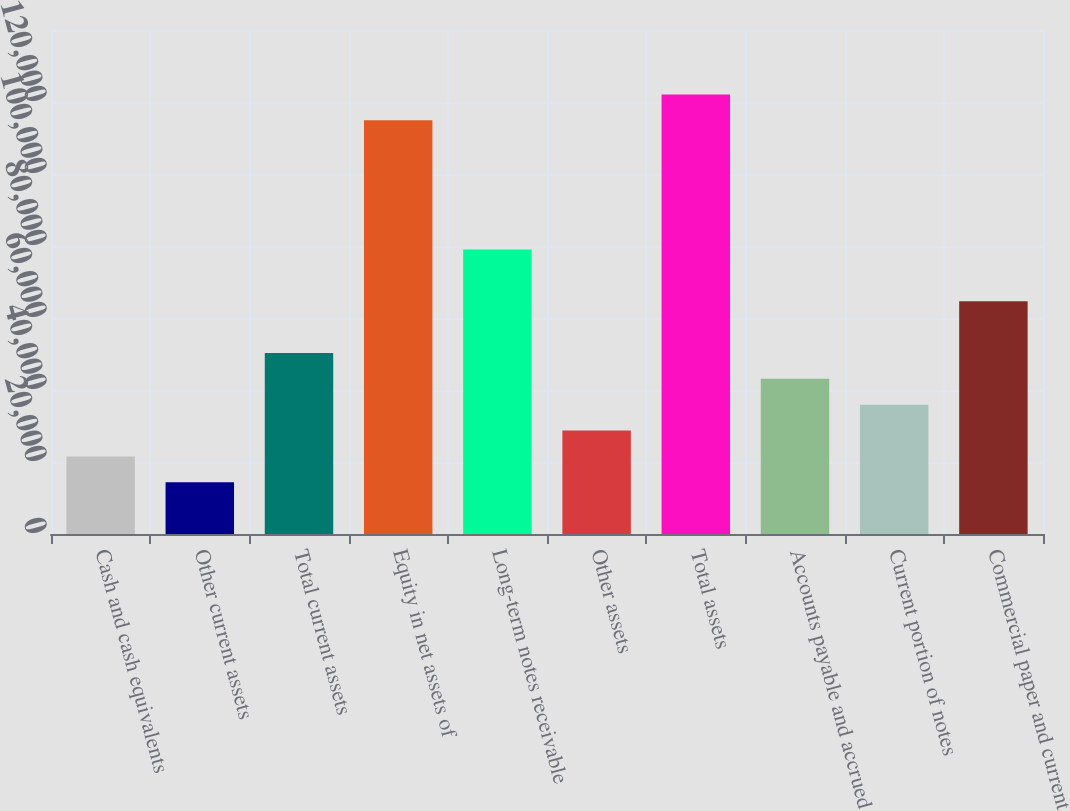Convert chart to OTSL. <chart><loc_0><loc_0><loc_500><loc_500><bar_chart><fcel>Cash and cash equivalents<fcel>Other current assets<fcel>Total current assets<fcel>Equity in net assets of<fcel>Long-term notes receivable<fcel>Other assets<fcel>Total assets<fcel>Accounts payable and accrued<fcel>Current portion of notes<fcel>Commercial paper and current<nl><fcel>21555.4<fcel>14373.6<fcel>50282.6<fcel>114919<fcel>79009.8<fcel>28737.2<fcel>122101<fcel>43100.8<fcel>35919<fcel>64646.2<nl></chart> 